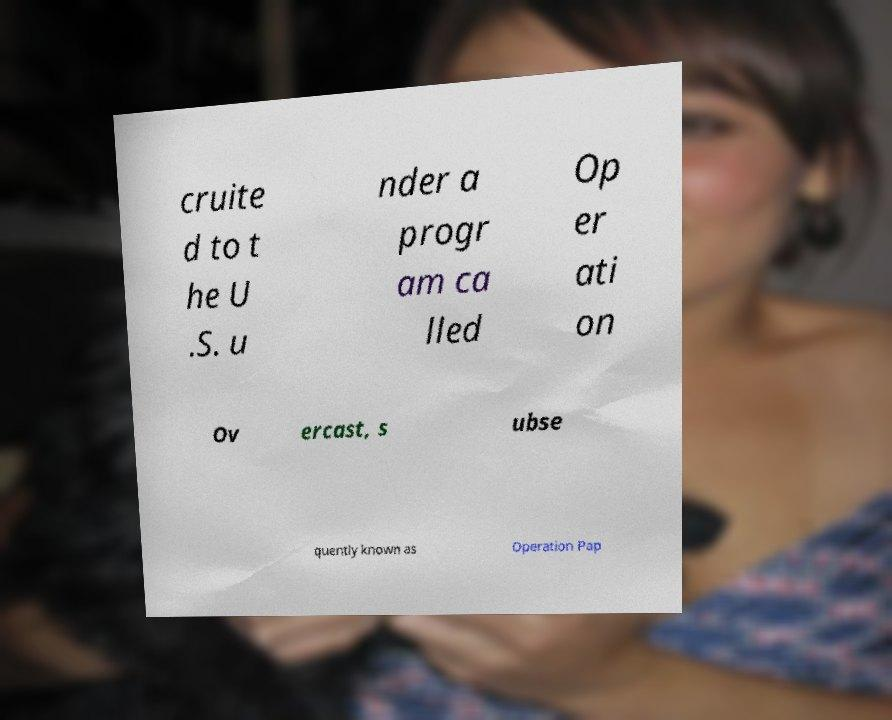Can you accurately transcribe the text from the provided image for me? cruite d to t he U .S. u nder a progr am ca lled Op er ati on Ov ercast, s ubse quently known as Operation Pap 